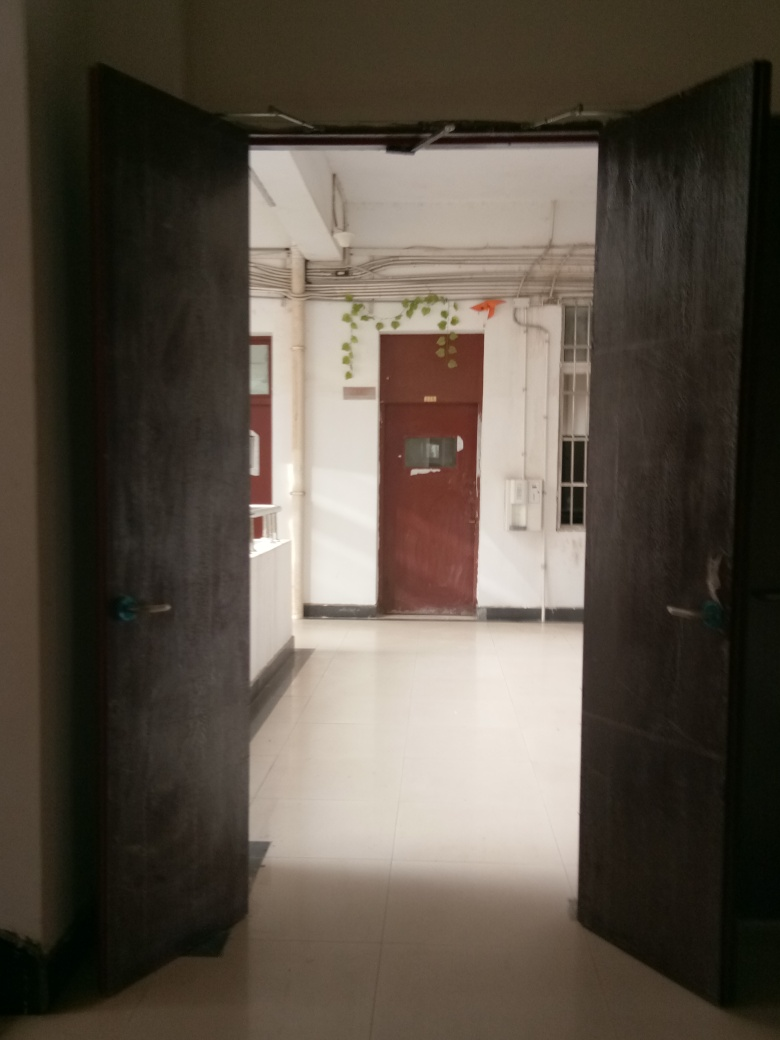What can be inferred about the usage and maintenance of this space? The space seems well-maintained, evidenced by the clean floors and organized appearance. The building likely receives regular traffic, indicated by the absence of debris or clutter in the hallway, suggesting it could be a professional or educational establishment. 